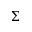Convert formula to latex. <formula><loc_0><loc_0><loc_500><loc_500>\Sigma</formula> 